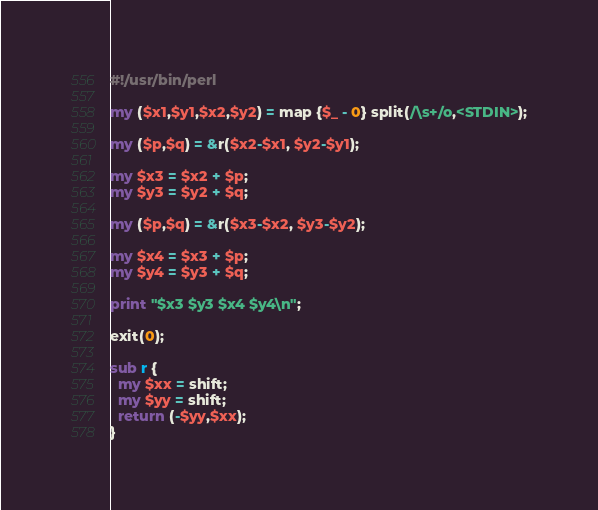<code> <loc_0><loc_0><loc_500><loc_500><_Perl_>#!/usr/bin/perl

my ($x1,$y1,$x2,$y2) = map {$_ - 0} split(/\s+/o,<STDIN>);

my ($p,$q) = &r($x2-$x1, $y2-$y1);

my $x3 = $x2 + $p; 
my $y3 = $y2 + $q;

my ($p,$q) = &r($x3-$x2, $y3-$y2);

my $x4 = $x3 + $p;
my $y4 = $y3 + $q;

print "$x3 $y3 $x4 $y4\n";

exit(0);

sub r {
  my $xx = shift;
  my $yy = shift;
  return (-$yy,$xx);
}
</code> 